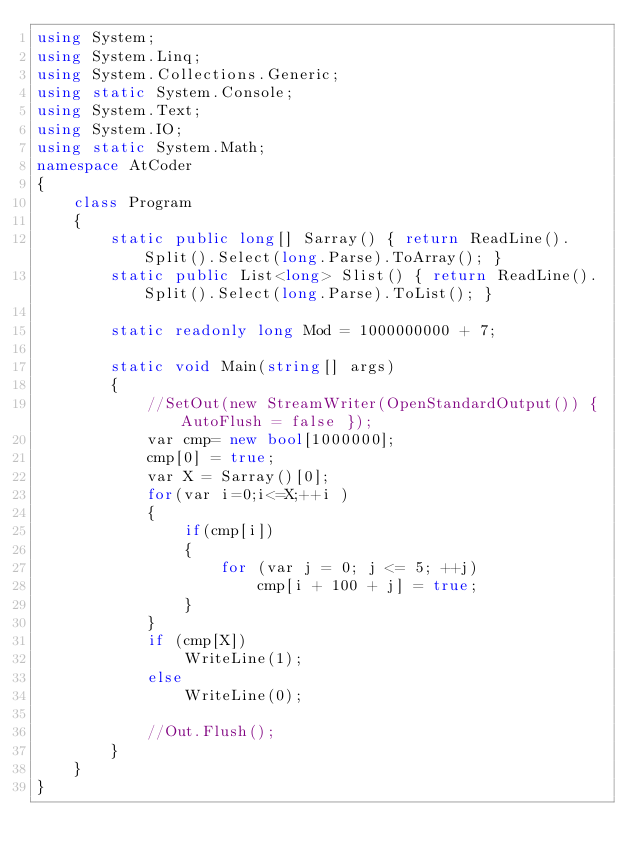<code> <loc_0><loc_0><loc_500><loc_500><_C#_>using System;
using System.Linq;
using System.Collections.Generic;
using static System.Console;
using System.Text;
using System.IO;
using static System.Math;
namespace AtCoder
{
    class Program
    {
        static public long[] Sarray() { return ReadLine().Split().Select(long.Parse).ToArray(); }
        static public List<long> Slist() { return ReadLine().Split().Select(long.Parse).ToList(); }

        static readonly long Mod = 1000000000 + 7;

        static void Main(string[] args)
        {
            //SetOut(new StreamWriter(OpenStandardOutput()) { AutoFlush = false });
            var cmp= new bool[1000000];
            cmp[0] = true;
            var X = Sarray()[0];
            for(var i=0;i<=X;++i )
            {
                if(cmp[i])
                {
                    for (var j = 0; j <= 5; ++j)
                        cmp[i + 100 + j] = true;
                }
            }
            if (cmp[X])
                WriteLine(1);
            else
                WriteLine(0);

            //Out.Flush();
        }
    }
}</code> 